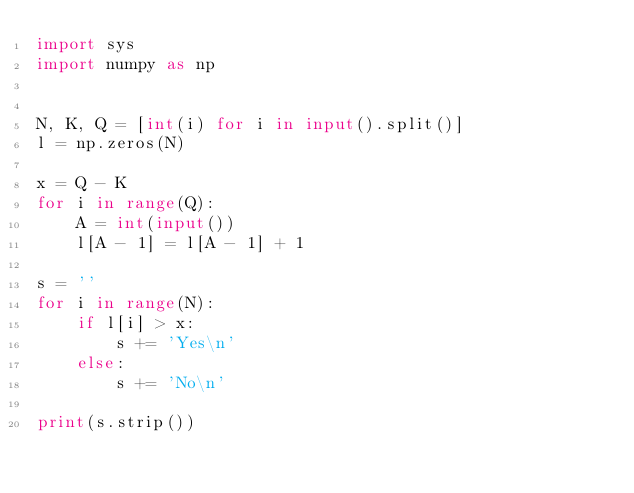Convert code to text. <code><loc_0><loc_0><loc_500><loc_500><_Python_>import sys
import numpy as np


N, K, Q = [int(i) for i in input().split()]
l = np.zeros(N)

x = Q - K
for i in range(Q):
    A = int(input())
    l[A - 1] = l[A - 1] + 1

s = ''
for i in range(N):
    if l[i] > x:
        s += 'Yes\n'
    else:
        s += 'No\n'

print(s.strip())
</code> 